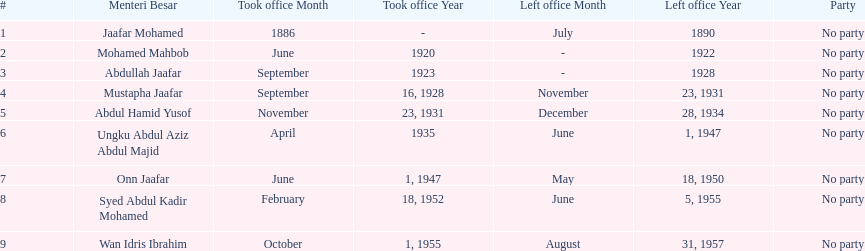What is the number of menteri besars that there have been during the pre-independence period? 9. 